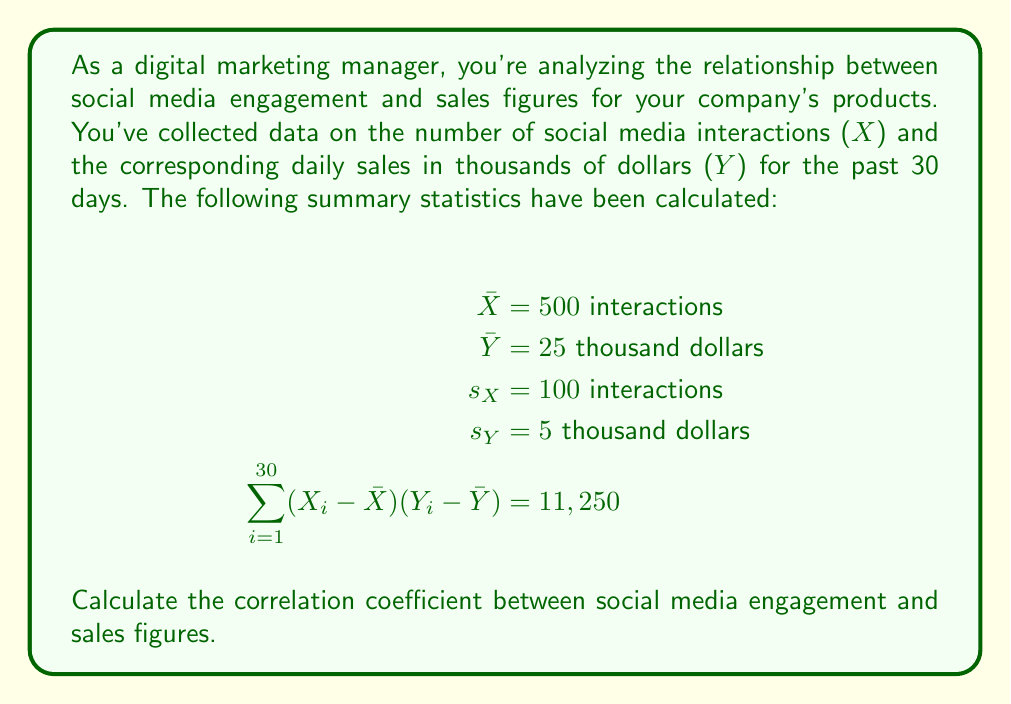Can you solve this math problem? To calculate the correlation coefficient between social media engagement (X) and sales figures (Y), we'll use the formula:

$$r_{XY} = \frac{\sum_{i=1}^{n} (X_i - \bar{X})(Y_i - \bar{Y})}{(n-1)s_X s_Y}$$

Where:
- $r_{XY}$ is the correlation coefficient
- $n$ is the number of data points (30 in this case)
- $s_X$ and $s_Y$ are the sample standard deviations of X and Y respectively

Step 1: We already have $\sum_{i=1}^{30} (X_i - \bar{X})(Y_i - \bar{Y}) = 11,250$

Step 2: Calculate $(n-1)s_X s_Y$:
$$(30-1) \cdot 100 \cdot 5 = 29 \cdot 100 \cdot 5 = 14,500$$

Step 3: Divide the sum from Step 1 by the result from Step 2:

$$r_{XY} = \frac{11,250}{14,500} = 0.7759$$

Therefore, the correlation coefficient between social media engagement and sales figures is approximately 0.7759.
Answer: $r_{XY} \approx 0.7759$ 